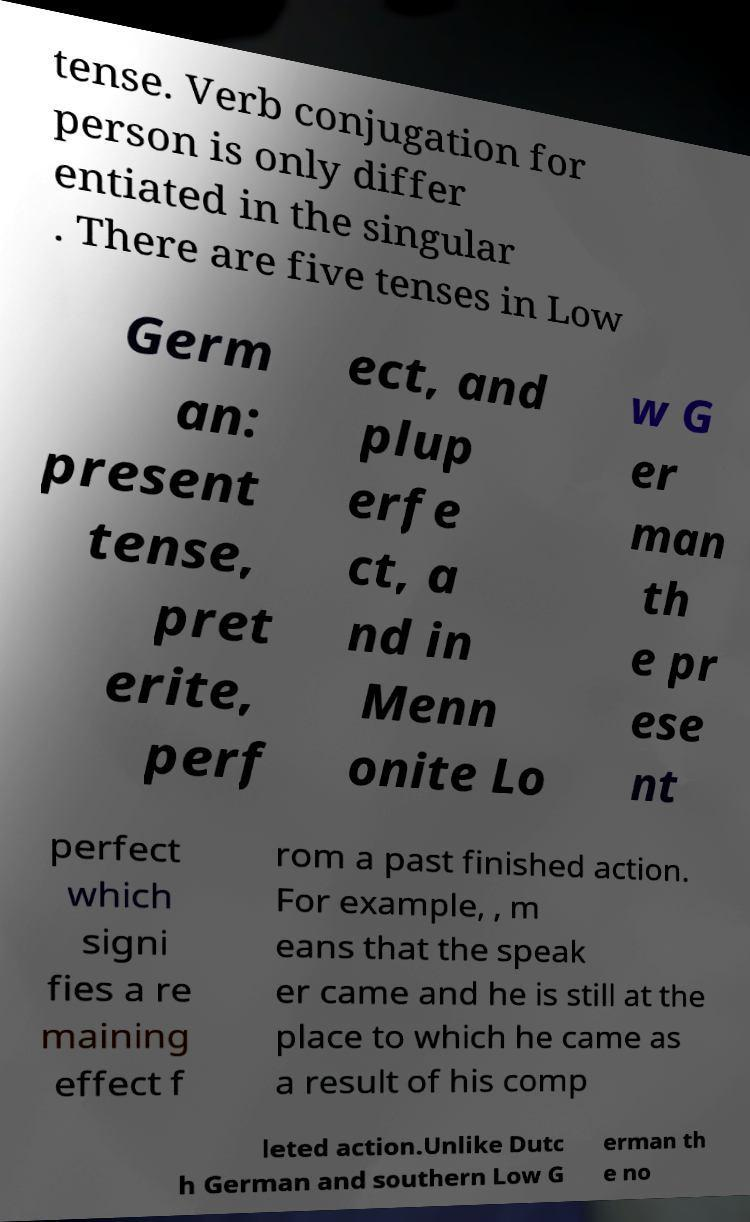Can you accurately transcribe the text from the provided image for me? tense. Verb conjugation for person is only differ entiated in the singular . There are five tenses in Low Germ an: present tense, pret erite, perf ect, and plup erfe ct, a nd in Menn onite Lo w G er man th e pr ese nt perfect which signi fies a re maining effect f rom a past finished action. For example, , m eans that the speak er came and he is still at the place to which he came as a result of his comp leted action.Unlike Dutc h German and southern Low G erman th e no 